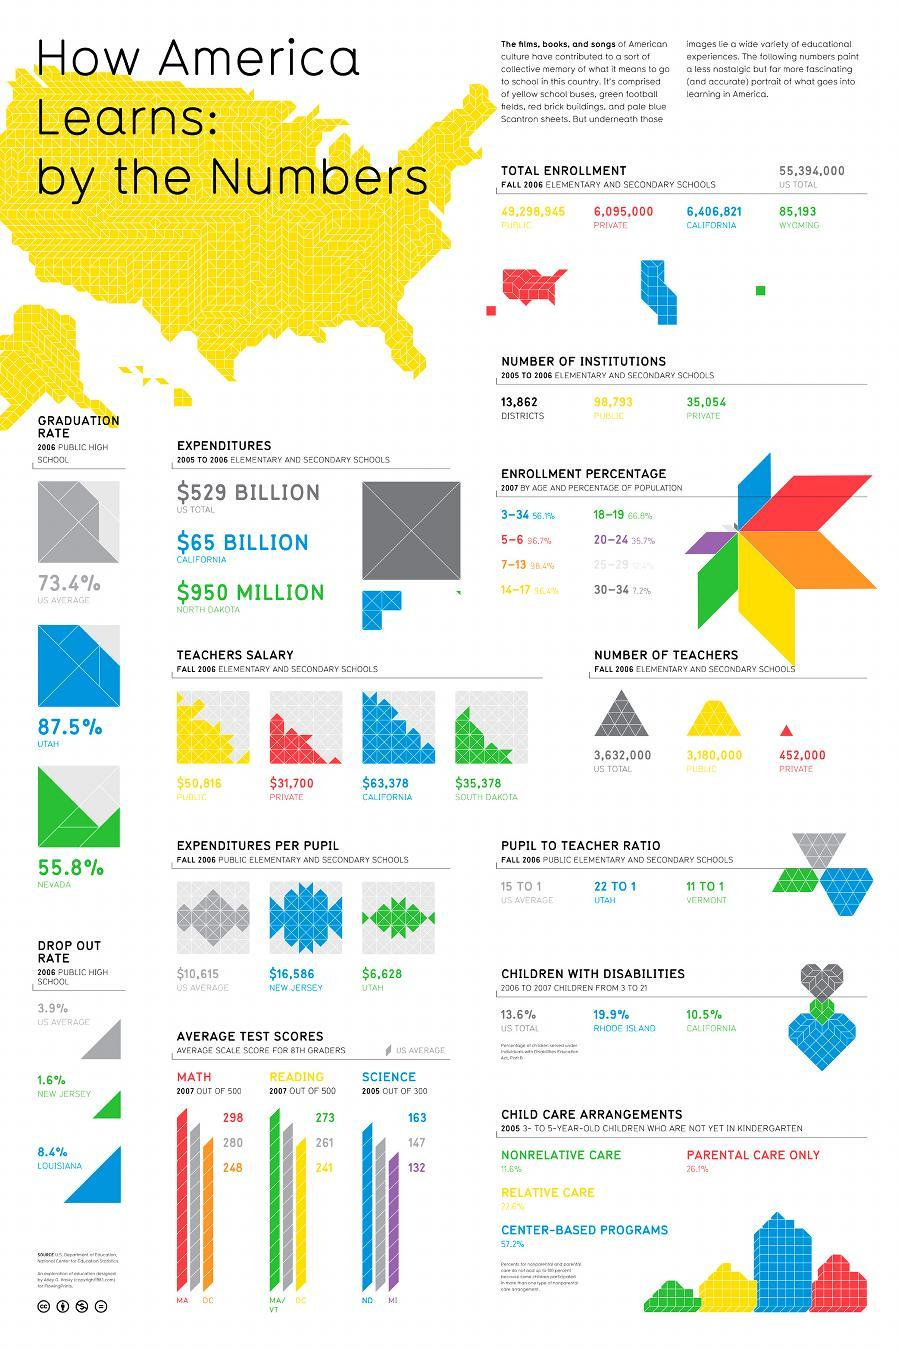what is the average reading score of US 8th graders out of 500 in 2007?
Answer the question with a short phrase. 261 the percentage of children with disabilities is higher in which region - California or Rhode Island? Rhode Island In which region, expenditure per pupil is higher - Utah or New Jersey? New Jersey what is the average science score of US 8th graders out of 500 in 2007? 147 Teachers salary of Fall 2006 is highest among public or private? public what is the difference in number of teachers from public sector and private sector? 2728000 what is the average math score of US 8th graders out of 500 in 2007? 280 Drop out rate of 2006 is highest among which region - New Jersey or Louisiana? Louisiana Graduation rate of 2006 is highest among which region - Nevada or Utah? Utah what is the difference in salary of school teachers from public sector and private sector in dollars? 19116 total number of enrollment is higher in which region - California or Wyoming? California what is the difference in salary of school teachers from California and North Dakota in dollars? 28000 In which region, drop out rate of 2006 is lower than US average? New Jersey In which region, graduation rate of 2006 is lower than US average? Nevada total number of enrollment is higher in which sector - public or private? public 